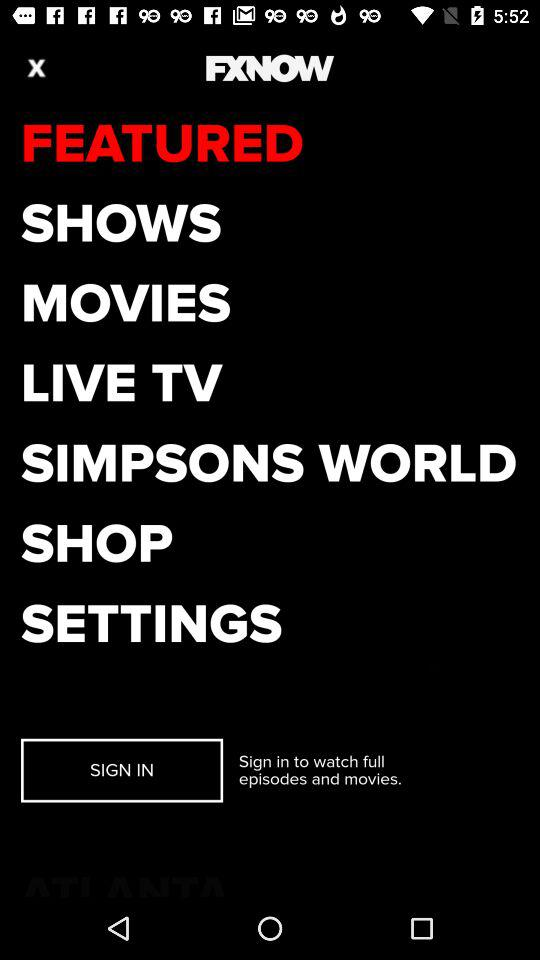How can users watch full episodes and movies? Users can watch full episodes and movies by signing in. 